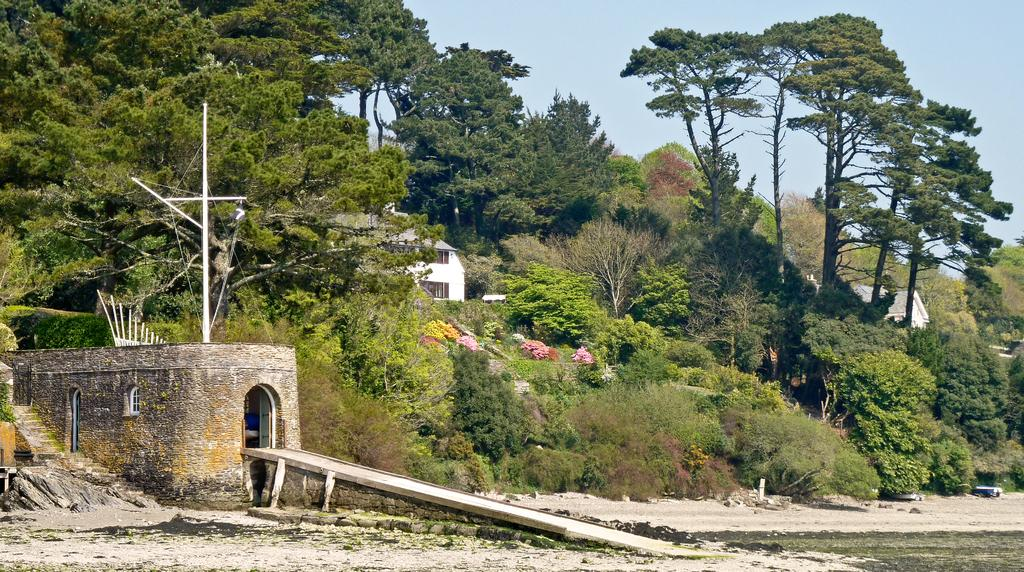What type of structure is located on the left side of the image? There is a house with a ramp on the left side of the image. What can be seen in the background of the image? There are trees and houses in the background of the image, as well as the sky. What is present at the bottom of the image? There is sand at the bottom of the image. Can you see any quicksand in the image? No, there is no quicksand present in the image. What type of bushes can be seen growing near the house in the image? There is no mention of bushes in the image; only trees are mentioned in the background. 